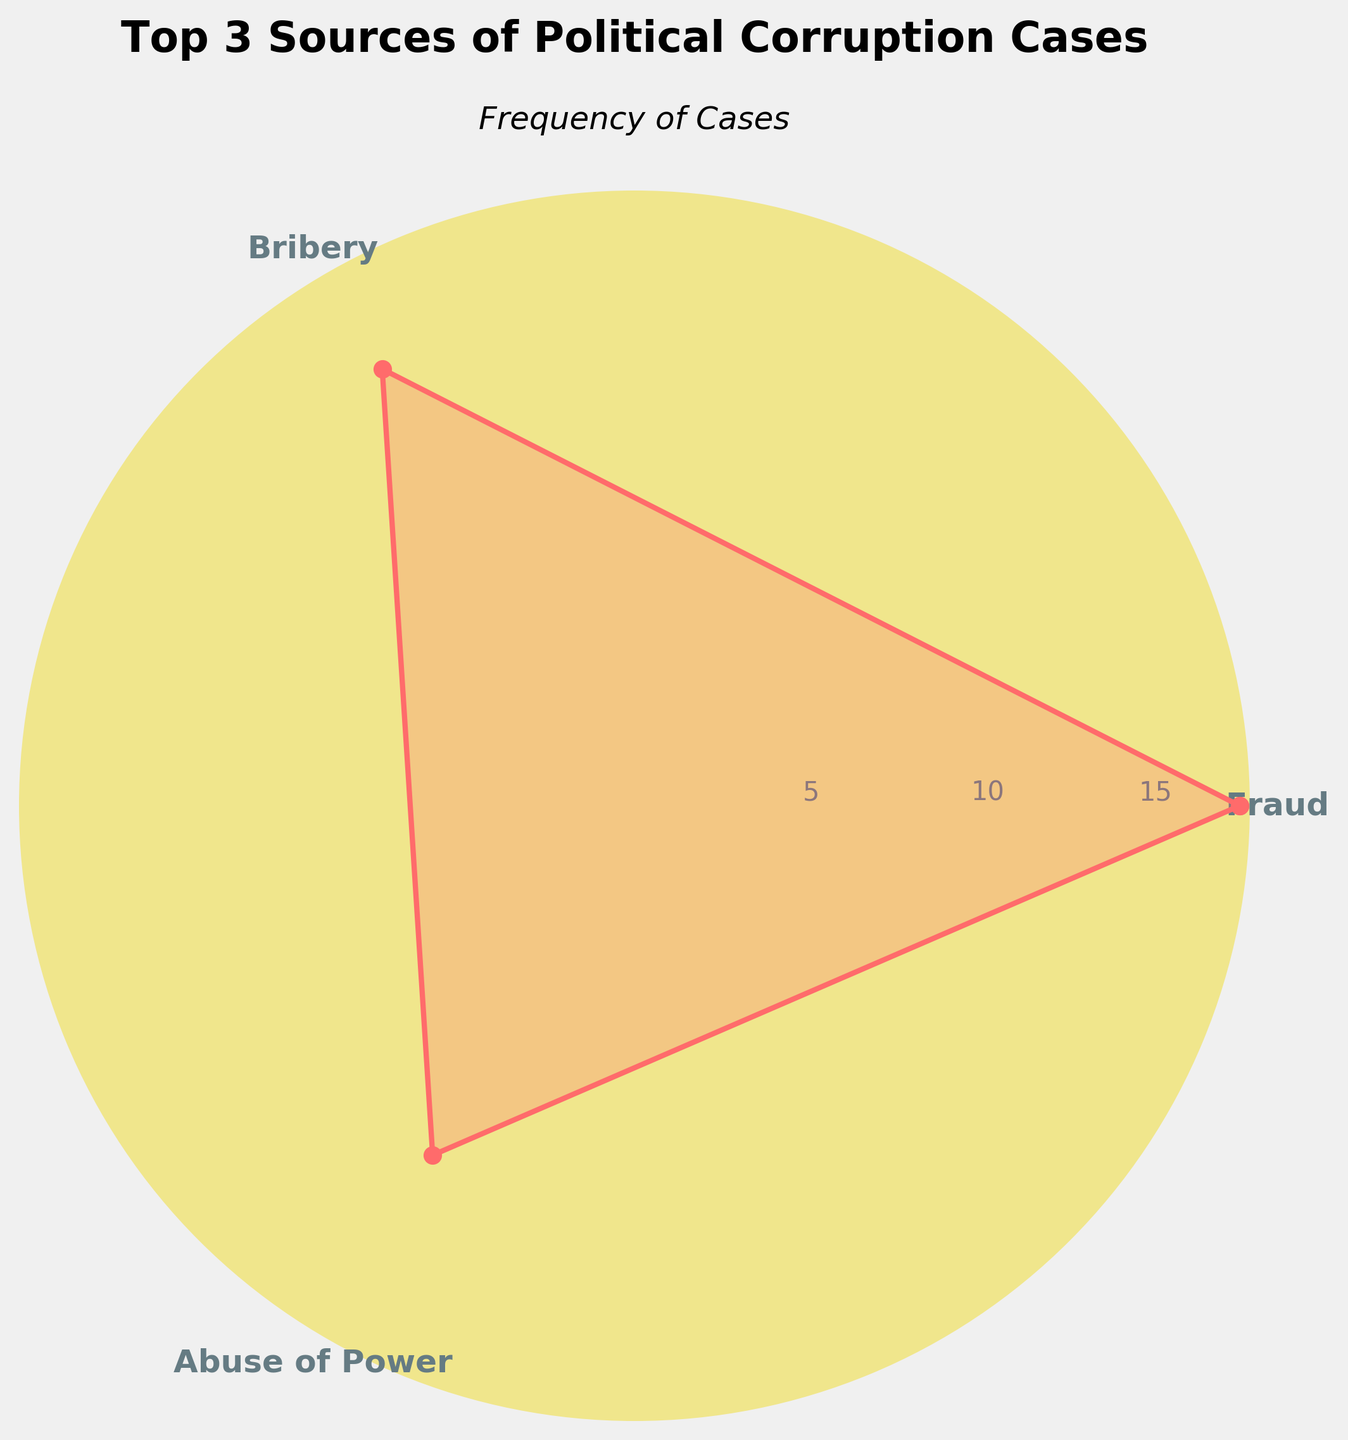What is the title of the figure? The title of the figure is displayed at the top, providing a quick summary of the data being presented.
Answer: Top 3 Sources of Political Corruption Cases What is the category with the highest frequency? The value at the highest point on the radial axis corresponds to the category with the highest frequency, typically signified by its position and annotation.
Answer: Fraud What is the range of the frequency values shown in the figure? The range is determined by taking the difference between the highest and lowest values on the radial axis.
Answer: 8 Which category has the second highest frequency? The second highest frequency can be identified by comparing the magnitudes of the radial lines for the top three categories.
Answer: Bribery What color is used to fill the plot data? Observing the filled area of the plot, its color is distinctly noticeable.
Answer: Red Which radial label values are displayed in the figure? The radial labels are the numeric values positioned around the radial axis, indicating frequency measurements.
Answer: 5 and 10 What is the category with the lowest frequency among the top 3? By comparing the categories and their corresponding radial lengths, the category with the smallest value is identified.
Answer: Abuse of Power What is the average frequency of the top 3 categories? To find the average, sum the frequencies of the top three categories and divide by 3. Mathematically, (18 + 15 + 12) / 3 = 45 / 3 = 15.
Answer: 15 How much higher is the frequency of Fraud compared to Abuse of Power? By subtracting the frequency of Abuse of Power from the frequency of Fraud, we determine the difference. Mathematically, 18 - 12 = 6.
Answer: 6 